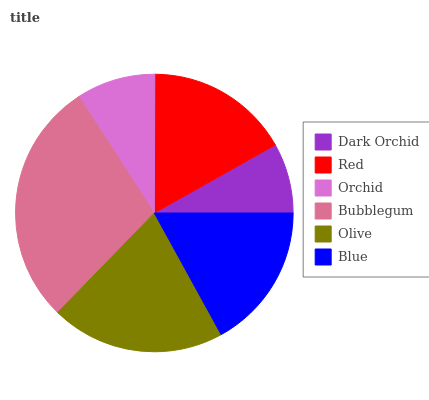Is Dark Orchid the minimum?
Answer yes or no. Yes. Is Bubblegum the maximum?
Answer yes or no. Yes. Is Red the minimum?
Answer yes or no. No. Is Red the maximum?
Answer yes or no. No. Is Red greater than Dark Orchid?
Answer yes or no. Yes. Is Dark Orchid less than Red?
Answer yes or no. Yes. Is Dark Orchid greater than Red?
Answer yes or no. No. Is Red less than Dark Orchid?
Answer yes or no. No. Is Blue the high median?
Answer yes or no. Yes. Is Red the low median?
Answer yes or no. Yes. Is Red the high median?
Answer yes or no. No. Is Orchid the low median?
Answer yes or no. No. 